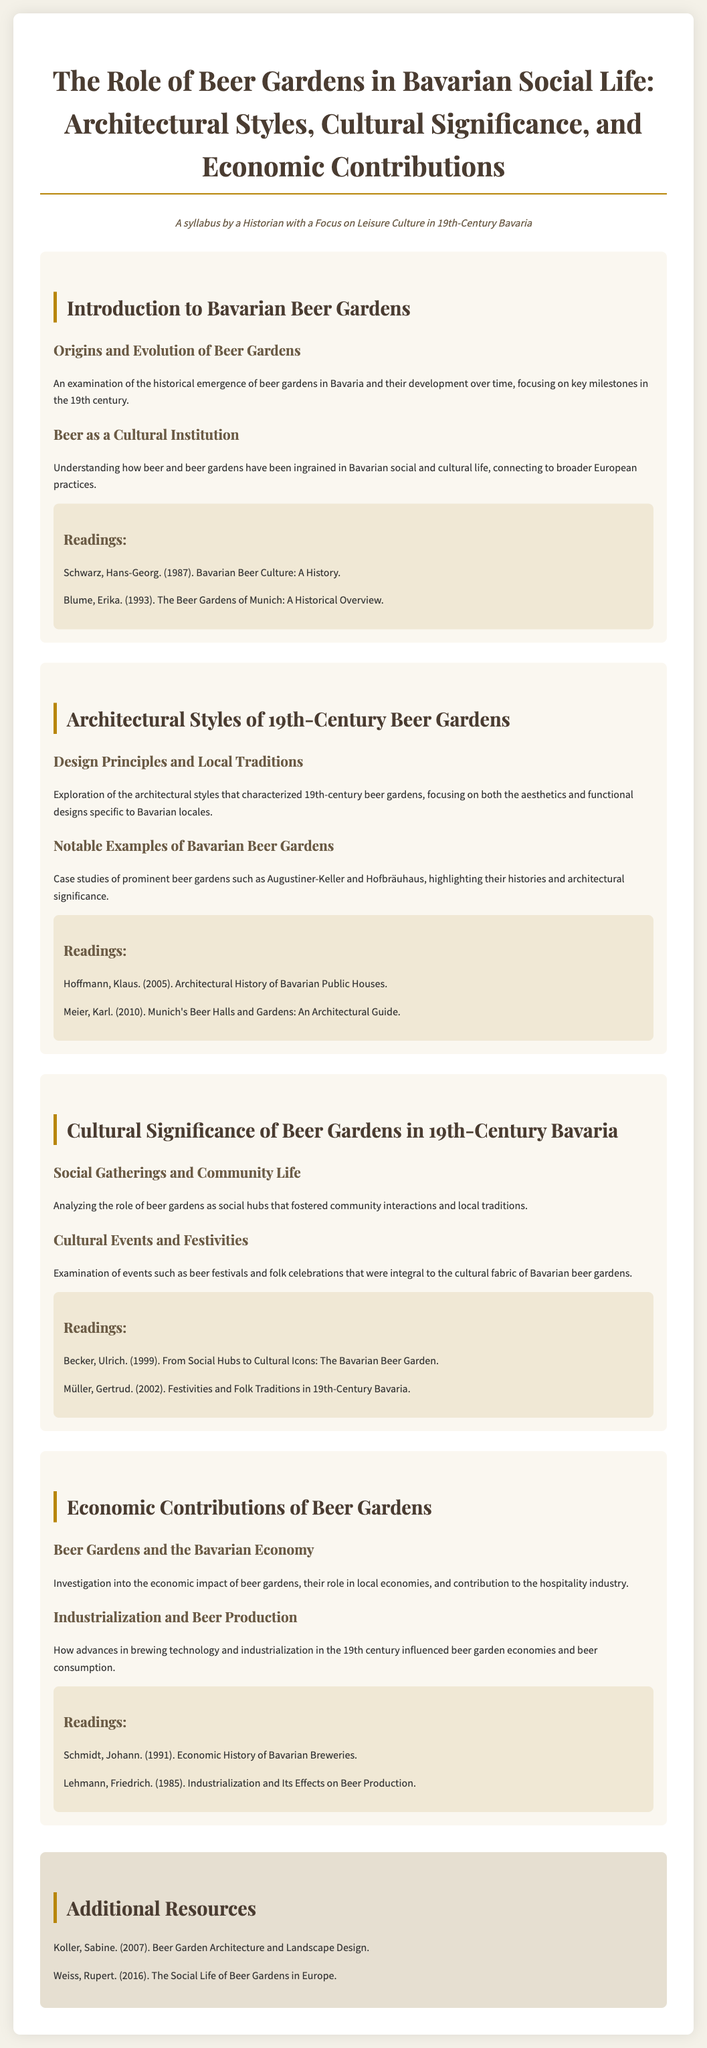What are the origins of beer gardens? The syllabus states it provides an examination of the historical emergence of beer gardens in Bavaria and their development over time.
Answer: Origins and Evolution of Beer Gardens What highlighted the architectural styles of beer gardens? The document mentions an exploration of the architectural styles that characterized 19th-century beer gardens, including aesthetics and functional designs.
Answer: Design Principles and Local Traditions Which case studies are mentioned in relation to beer gardens? The syllabus specifically mentions prominent beer gardens such as Augustiner-Keller and Hofbräuhaus as case studies with architectural significance.
Answer: Augustiner-Keller and Hofbräuhaus What is the focus of the lecture on cultural significance? The lecture analyzes the role of beer gardens as social hubs fostering community interactions and local traditions.
Answer: Social Gatherings and Community Life Which reading is related to the economic impact of beer gardens? The syllabus lists readings that investigate the economic impact of beer gardens, highlighting their role in local economies.
Answer: Schmidt, Johann. (1991). Economic History of Bavarian Breweries What year was the reading about Bavarian beer culture published? The document states that "Bavarian Beer Culture: A History" was published in 1987.
Answer: 1987 Which module discusses beer festivals? The document specifies that beer festivals are discussed in the context of cultural events and festivities within the beer gardens.
Answer: Cultural Significance of Beer Gardens in 19th-Century Bavaria What is included in the additional resources? The syllabus includes extra readings that provide further insights into beer garden architecture and social life.
Answer: Beer Garden Architecture and Landscape Design What is a recurring theme in the document? The recurring theme throughout the syllabus relates to the significance of beer gardens in Bavarian social life, culture, and economy.
Answer: Social Life of Beer Gardens 